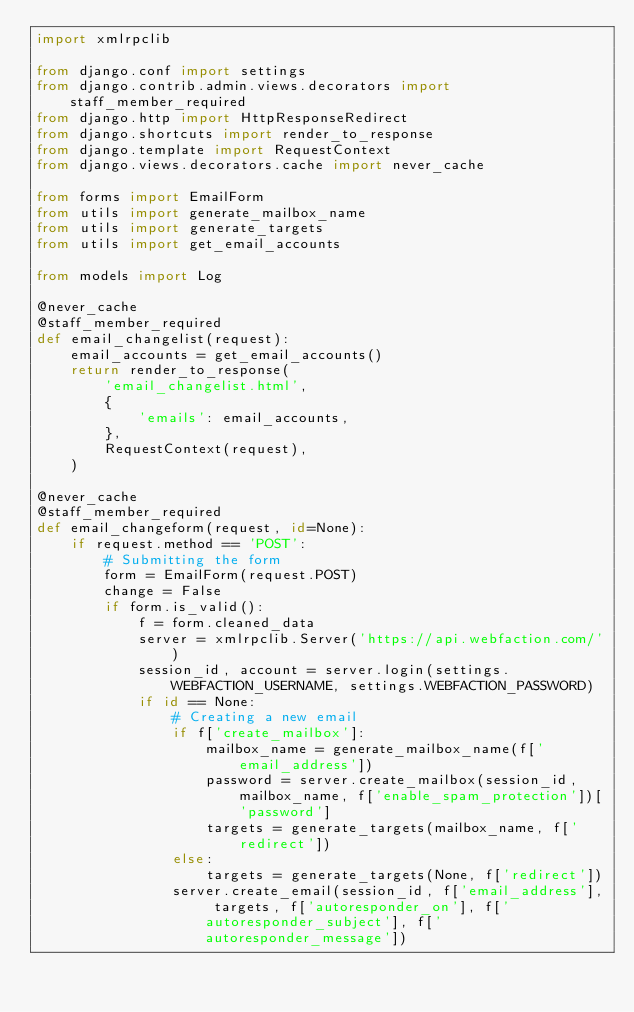<code> <loc_0><loc_0><loc_500><loc_500><_Python_>import xmlrpclib

from django.conf import settings
from django.contrib.admin.views.decorators import staff_member_required
from django.http import HttpResponseRedirect
from django.shortcuts import render_to_response
from django.template import RequestContext
from django.views.decorators.cache import never_cache

from forms import EmailForm
from utils import generate_mailbox_name
from utils import generate_targets
from utils import get_email_accounts

from models import Log

@never_cache
@staff_member_required
def email_changelist(request):
    email_accounts = get_email_accounts()
    return render_to_response(
        'email_changelist.html',
        {
            'emails': email_accounts,
        },
        RequestContext(request),
    )

@never_cache
@staff_member_required
def email_changeform(request, id=None):
    if request.method == 'POST':
        # Submitting the form
        form = EmailForm(request.POST)
        change = False
        if form.is_valid():
            f = form.cleaned_data
            server = xmlrpclib.Server('https://api.webfaction.com/')
            session_id, account = server.login(settings.WEBFACTION_USERNAME, settings.WEBFACTION_PASSWORD)
            if id == None:
                # Creating a new email
                if f['create_mailbox']:
                    mailbox_name = generate_mailbox_name(f['email_address'])
                    password = server.create_mailbox(session_id, mailbox_name, f['enable_spam_protection'])['password']
                    targets = generate_targets(mailbox_name, f['redirect'])
                else:
                    targets = generate_targets(None, f['redirect'])
                server.create_email(session_id, f['email_address'], targets, f['autoresponder_on'], f['autoresponder_subject'], f['autoresponder_message'])</code> 